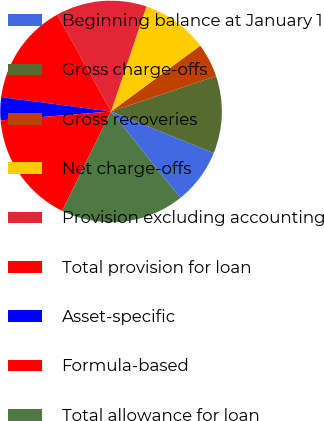Convert chart. <chart><loc_0><loc_0><loc_500><loc_500><pie_chart><fcel>Beginning balance at January 1<fcel>Gross charge-offs<fcel>Gross recoveries<fcel>Net charge-offs<fcel>Provision excluding accounting<fcel>Total provision for loan<fcel>Asset-specific<fcel>Formula-based<fcel>Total allowance for loan<nl><fcel>8.12%<fcel>11.3%<fcel>4.94%<fcel>9.71%<fcel>13.26%<fcel>14.85%<fcel>3.35%<fcel>16.44%<fcel>18.03%<nl></chart> 